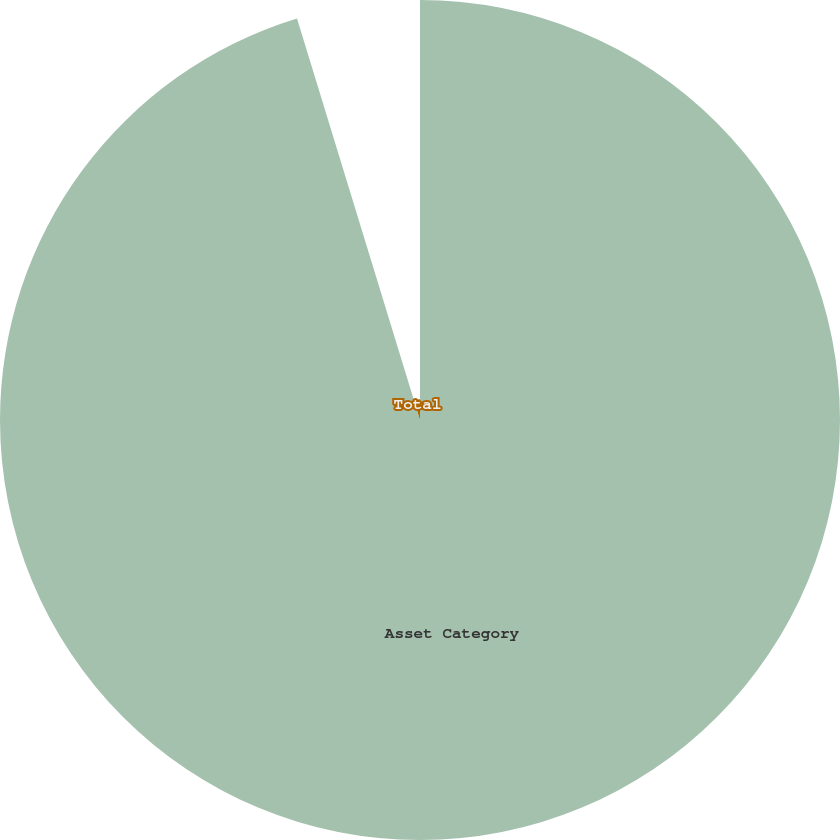Convert chart. <chart><loc_0><loc_0><loc_500><loc_500><pie_chart><fcel>Asset Category<fcel>Total<nl><fcel>95.27%<fcel>4.73%<nl></chart> 